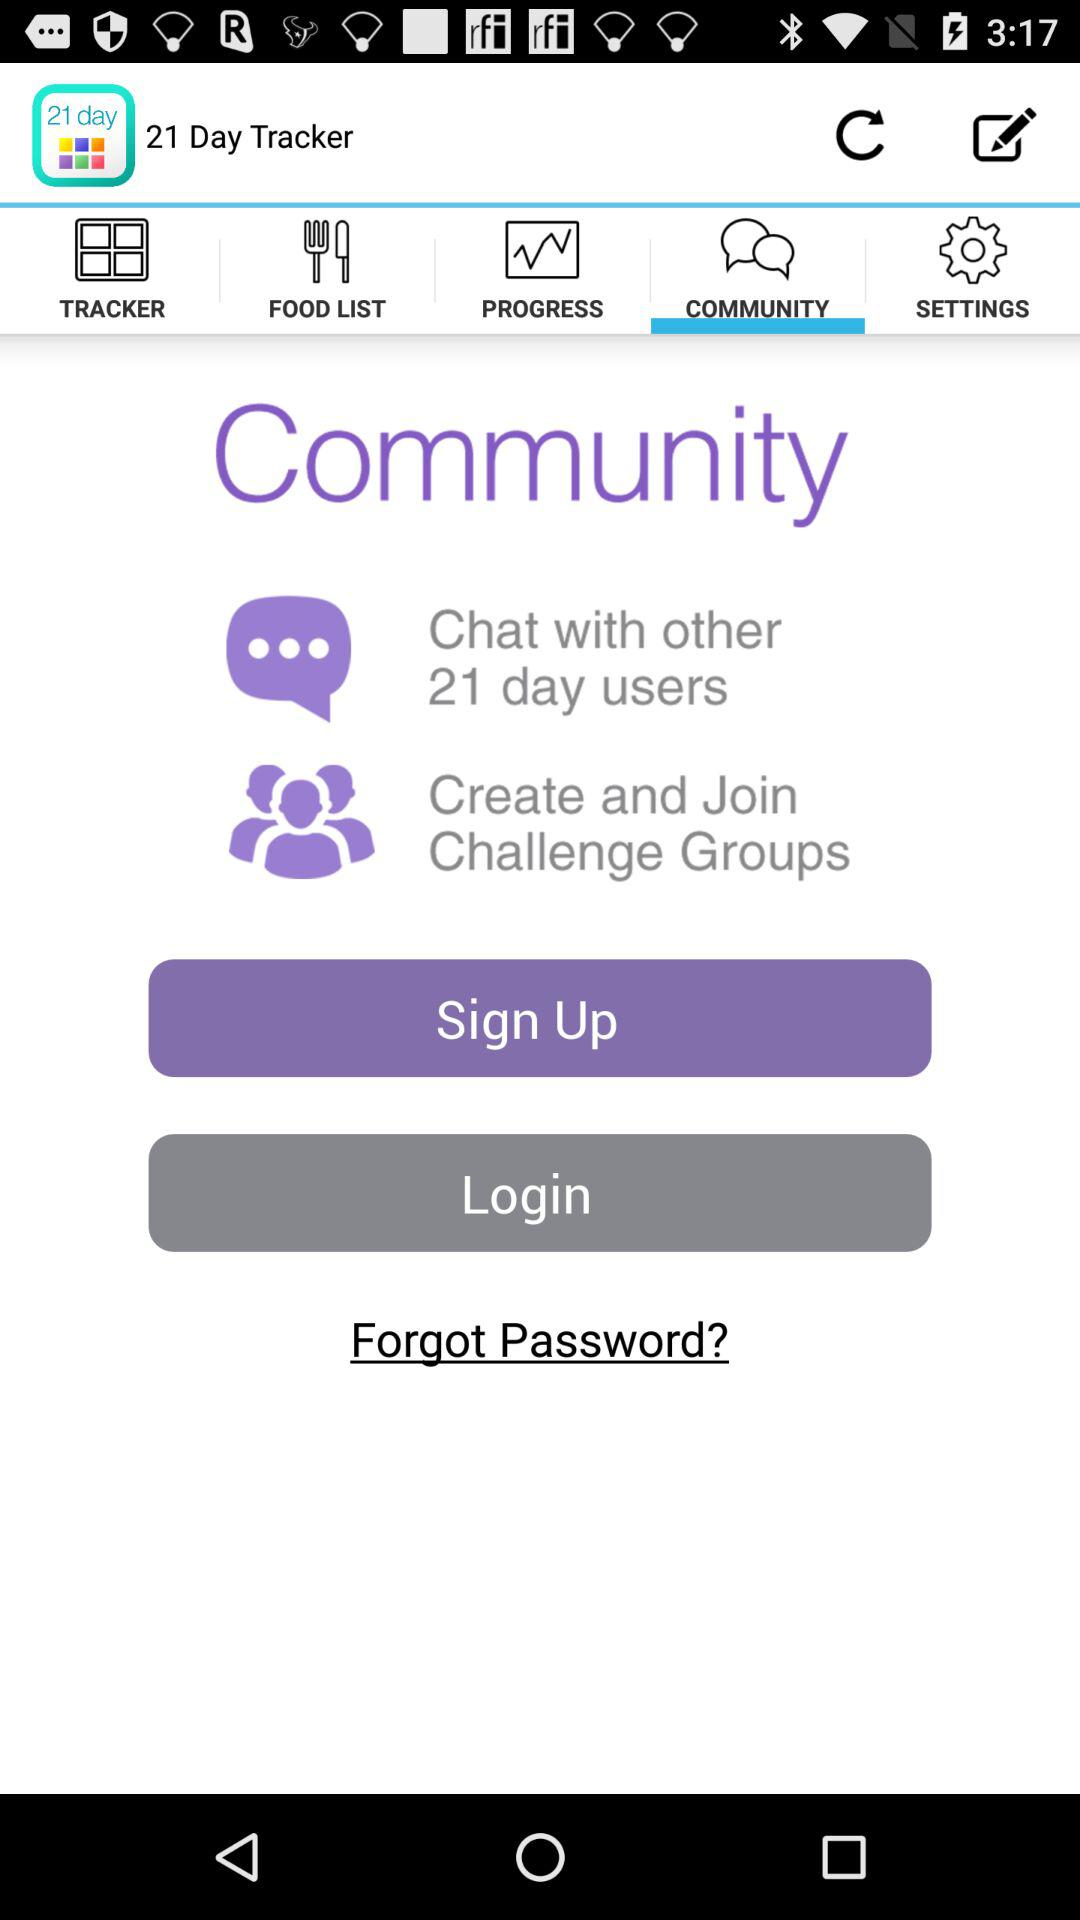Which tab is currently selected? The currently selected tab is "COMMUNITY". 